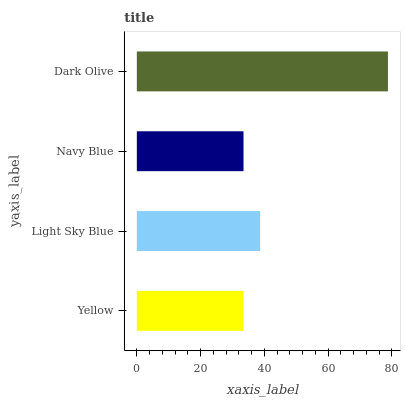Is Navy Blue the minimum?
Answer yes or no. Yes. Is Dark Olive the maximum?
Answer yes or no. Yes. Is Light Sky Blue the minimum?
Answer yes or no. No. Is Light Sky Blue the maximum?
Answer yes or no. No. Is Light Sky Blue greater than Yellow?
Answer yes or no. Yes. Is Yellow less than Light Sky Blue?
Answer yes or no. Yes. Is Yellow greater than Light Sky Blue?
Answer yes or no. No. Is Light Sky Blue less than Yellow?
Answer yes or no. No. Is Light Sky Blue the high median?
Answer yes or no. Yes. Is Yellow the low median?
Answer yes or no. Yes. Is Yellow the high median?
Answer yes or no. No. Is Light Sky Blue the low median?
Answer yes or no. No. 